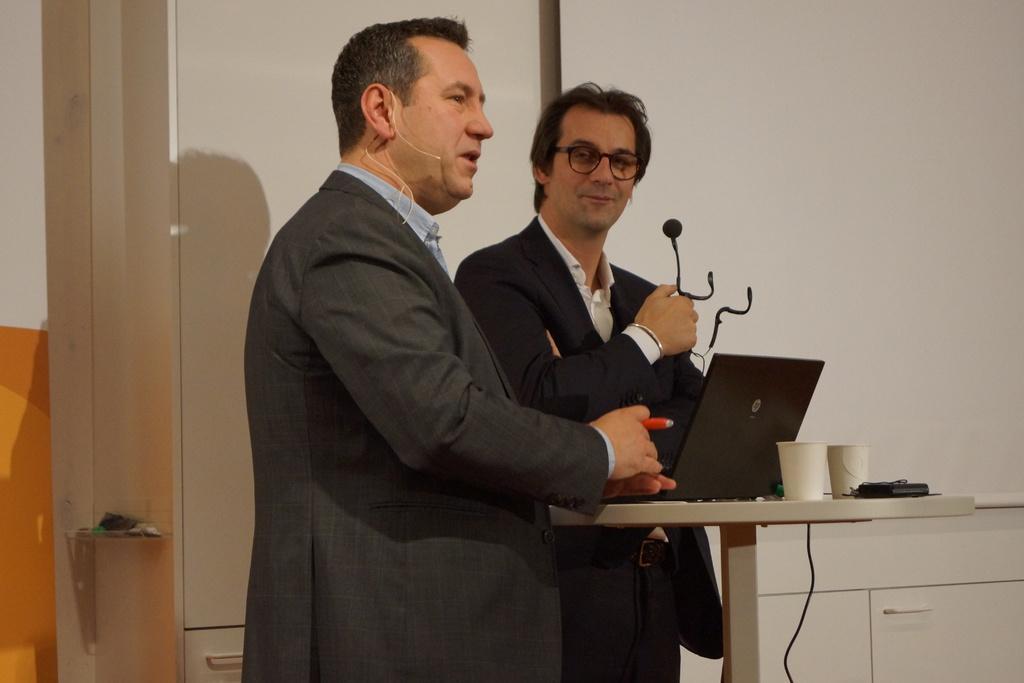How would you summarize this image in a sentence or two? Here, at the middle there are two men standing, one is holding a black color microphone, there is a table, on that table there is a black color laptop, at the background there is a white color wall. 